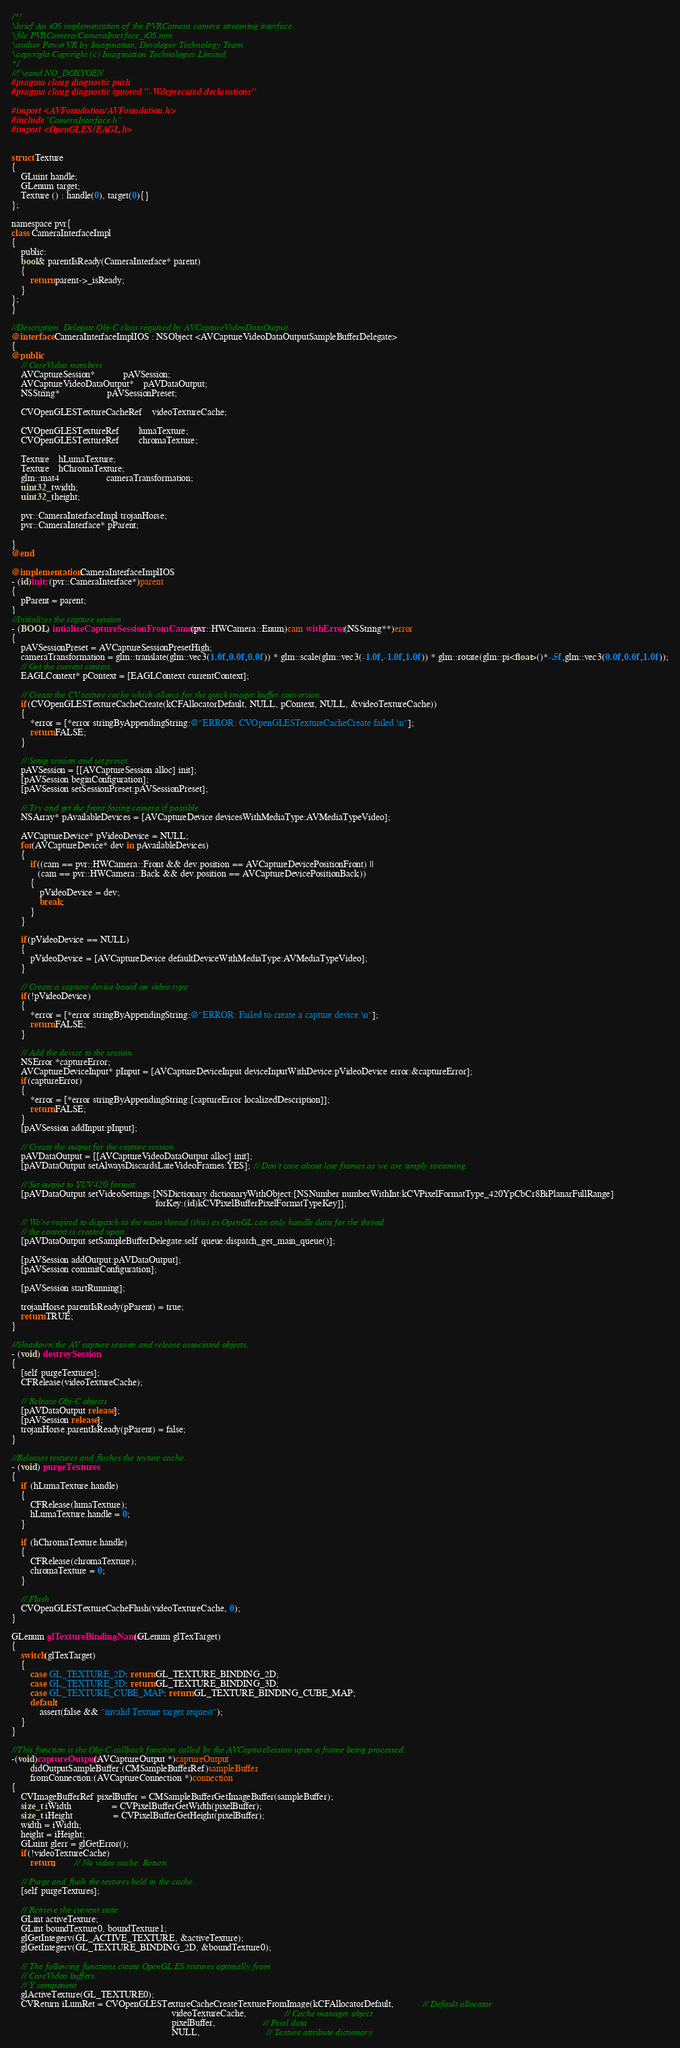Convert code to text. <code><loc_0><loc_0><loc_500><loc_500><_ObjectiveC_>/*!
\brief An iOS implementation of the PVRCamera camera streaming interface.
\file PVRCamera/CameraInterface_iOS.mm
\author PowerVR by Imagination, Developer Technology Team
\copyright Copyright (c) Imagination Technologies Limited.
*/
//!\cond NO_DOXYGEN
#pragma clang diagnostic push
#pragma clang diagnostic ignored "-Wdeprecated-declarations"

#import <AVFoundation/AVFoundation.h>
#include "CameraInterface.h"
#import <OpenGLES/EAGL.h>


struct Texture
{
	GLuint handle;
	GLenum target;
	Texture () : handle(0), target(0){}
};

namespace pvr{
class CameraInterfaceImpl
{
	public:
	bool& parentIsReady(CameraInterface* parent)
	{
		return parent->_isReady;
	}
};
}

//Description  Delegate Obj-C class required by AVCaptureVideoDataOutput
@interface CameraInterfaceImplIOS : NSObject <AVCaptureVideoDataOutputSampleBufferDelegate>
{
@public
	// CoreVideo members
	AVCaptureSession*			pAVSession;
	AVCaptureVideoDataOutput*	pAVDataOutput;
	NSString*					pAVSessionPreset;

	CVOpenGLESTextureCacheRef	videoTextureCache;
	
	CVOpenGLESTextureRef		lumaTexture;
	CVOpenGLESTextureRef		chromaTexture;

	Texture	hLumaTexture;
	Texture	hChromaTexture;
	glm::mat4					cameraTransformation;
	uint32_t width;
	uint32_t height;
	
	pvr::CameraInterfaceImpl trojanHorse;
	pvr::CameraInterface* pParent;
	
}
@end

@implementation CameraInterfaceImplIOS
- (id)init: (pvr::CameraInterface*)parent
{
	pParent = parent;
}
//Initializes the capture session
- (BOOL) intialiseCaptureSessionFromCamera:(pvr::HWCamera::Enum)cam withError:(NSString**)error
{
	pAVSessionPreset = AVCaptureSessionPresetHigh;
	cameraTransformation = glm::translate(glm::vec3(1.0f,0.0f,0.0f)) * glm::scale(glm::vec3(-1.0f,-1.0f,1.0f)) * glm::rotate(glm::pi<float>()*-.5f,glm::vec3(0.0f,0.0f,1.0f));
	// Get the current context.
	EAGLContext* pContext = [EAGLContext currentContext];

	// Create the CV texture cache which allows for the quick imager buffer conversion.
	if(CVOpenGLESTextureCacheCreate(kCFAllocatorDefault, NULL, pContext, NULL, &videoTextureCache))
	{
		*error = [*error stringByAppendingString:@"ERROR: CVOpenGLESTextureCacheCreate failed.\n"];
		return FALSE;
	}
	
	// Setup session and set preset.
	pAVSession = [[AVCaptureSession alloc] init];
	[pAVSession beginConfiguration];
	[pAVSession setSessionPreset:pAVSessionPreset];
	
	// Try and get the front facing camera if possible
	NSArray* pAvailableDevices = [AVCaptureDevice devicesWithMediaType:AVMediaTypeVideo];
	
	AVCaptureDevice* pVideoDevice = NULL;
	for(AVCaptureDevice* dev in pAvailableDevices)
	{
		if((cam == pvr::HWCamera::Front && dev.position == AVCaptureDevicePositionFront) ||
		   (cam == pvr::HWCamera::Back && dev.position == AVCaptureDevicePositionBack))
		{
			pVideoDevice = dev;
			break;
		}
	}

	if(pVideoDevice == NULL)
	{
		pVideoDevice = [AVCaptureDevice defaultDeviceWithMediaType:AVMediaTypeVideo];
	}
	
	// Create a capture device based on video type.
	if(!pVideoDevice)
	{
		*error = [*error stringByAppendingString:@"ERROR: Failed to create a capture device.\n"];
		return FALSE;
	}
	
	// Add the device to the session.
	NSError *captureError;
	AVCaptureDeviceInput* pInput = [AVCaptureDeviceInput deviceInputWithDevice:pVideoDevice error:&captureError];
	if(captureError)
	{
		*error = [*error stringByAppendingString:[captureError localizedDescription]];
		return FALSE;
	}
	[pAVSession addInput:pInput];
	
	// Create the output for the capture session.
	pAVDataOutput = [[AVCaptureVideoDataOutput alloc] init];
	[pAVDataOutput setAlwaysDiscardsLateVideoFrames:YES]; // Don't care about late frames as we are simply streaming.
	
	// Set output to YUV420 format.
	[pAVDataOutput setVideoSettings:[NSDictionary dictionaryWithObject:[NSNumber numberWithInt:kCVPixelFormatType_420YpCbCr8BiPlanarFullRange]
															 forKey:(id)kCVPixelBufferPixelFormatTypeKey]];
	
	// We're reqired to dispatch to the main thread (this) as OpenGL can only handle data for the thread
	// the context is created upon.
	[pAVDataOutput setSampleBufferDelegate:self queue:dispatch_get_main_queue()];
	
	[pAVSession addOutput:pAVDataOutput];
	[pAVSession commitConfiguration];
	
	[pAVSession startRunning];
	
	trojanHorse.parentIsReady(pParent) = true;
	return TRUE;
}

//Shutdown the AV capture session and release associated objects.
- (void) destroySession
{
	[self purgeTextures];
	CFRelease(videoTextureCache);

	// Release Obj-C objects
	[pAVDataOutput release];
	[pAVSession release];
	trojanHorse.parentIsReady(pParent) = false;
}

//Releases textures and flushes the texture cache.
- (void) purgeTextures
{
	if (hLumaTexture.handle)
	{
		CFRelease(lumaTexture);
		hLumaTexture.handle = 0;
	}
	
	if (hChromaTexture.handle)
	{
		CFRelease(chromaTexture);
		chromaTexture = 0;
	}
	
	// Flush
	CVOpenGLESTextureCacheFlush(videoTextureCache, 0);
}

GLenum glTextureBindingName(GLenum glTexTarget)
{
	switch(glTexTarget)
	{
		case GL_TEXTURE_2D: return GL_TEXTURE_BINDING_2D;
		case GL_TEXTURE_3D: return GL_TEXTURE_BINDING_3D;
		case GL_TEXTURE_CUBE_MAP: return GL_TEXTURE_BINDING_CUBE_MAP;
		default:
			assert(false && "invalid Texture target request");
	}
}

//This function is the Obj-C callback function called by the AVCaptureSession upon a frame being processed.
-(void)captureOutput:(AVCaptureOutput *)captureOutput
		didOutputSampleBuffer:(CMSampleBufferRef)sampleBuffer
		fromConnection:(AVCaptureConnection *)connection
{
	CVImageBufferRef pixelBuffer = CMSampleBufferGetImageBuffer(sampleBuffer);
	size_t iWidth				 = CVPixelBufferGetWidth(pixelBuffer);
	size_t iHeight				 = CVPixelBufferGetHeight(pixelBuffer);
	width = iWidth;
	height = iHeight;
	GLuint glerr = glGetError();
	if(!videoTextureCache)
		return;		// No video cache. Return.

	// Purge and flush the textures held in the cache.
	[self purgeTextures];

	// Retrieve the current state
	GLint activeTexture;
	GLint boundTexture0, boundTexture1;
	glGetIntegerv(GL_ACTIVE_TEXTURE, &activeTexture);
	glGetIntegerv(GL_TEXTURE_BINDING_2D, &boundTexture0);
	
	// The following functions create OpenGL:ES textures optimally from
	// CoreVideo buffers.
	// Y component
	glActiveTexture(GL_TEXTURE0);
	CVReturn iLumRet = CVOpenGLESTextureCacheCreateTextureFromImage(kCFAllocatorDefault,			// Default allocator
																	videoTextureCache,				// Cache manager object
																	pixelBuffer,					// Pixel data
																	NULL,							// Texture attribute dictionary</code> 